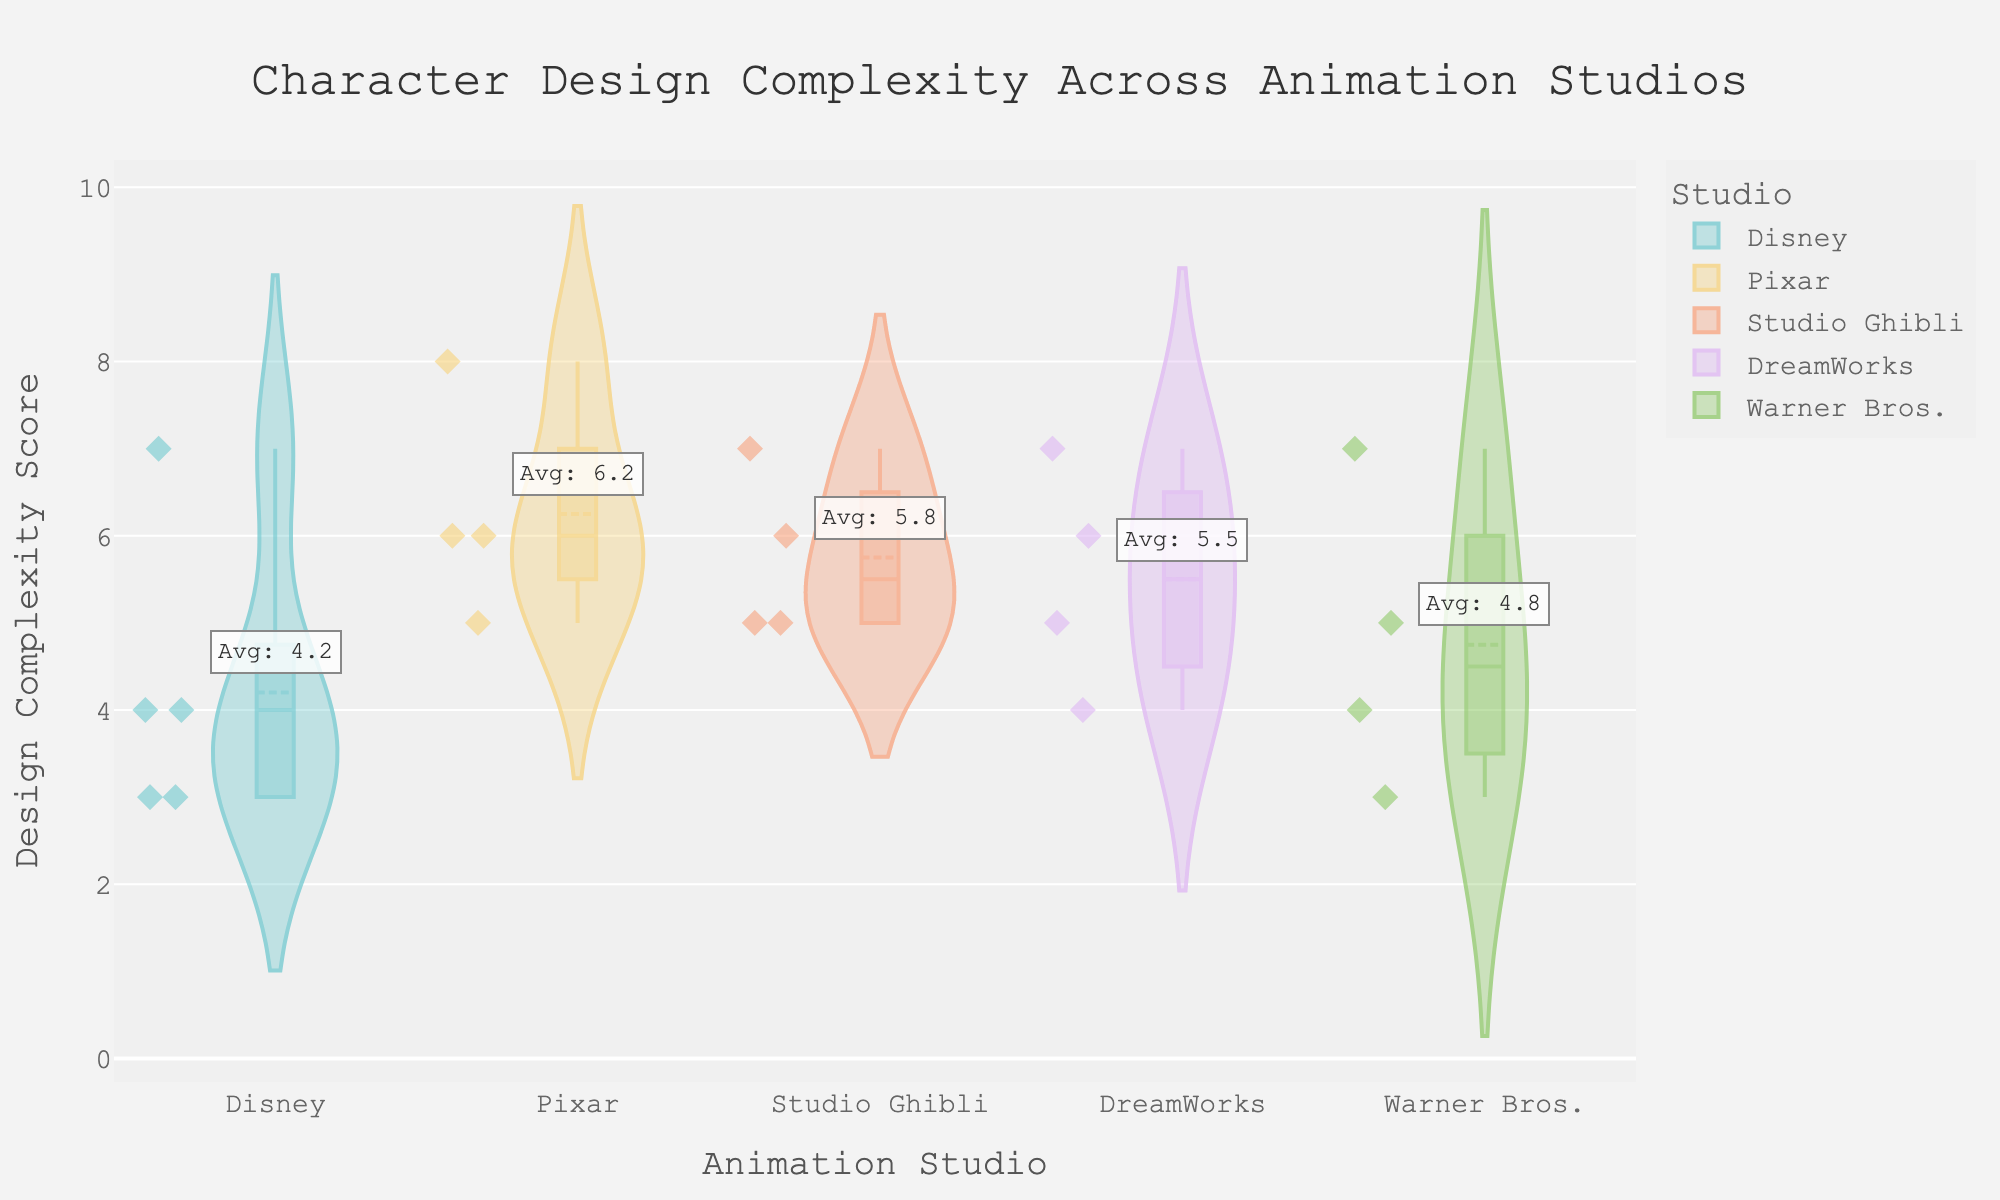What is the title of the figure? The title of the figure is displayed prominently at the top, and it reads "Character Design Complexity Across Animation Studios."
Answer: Character Design Complexity Across Animation Studios Which studio has the character with the highest design complexity score? We need to look at the highest points on the y-axis for each studio. The highest design complexity score is 8, which is associated with Pixar.
Answer: Pixar How many characters from Studio Ghibli are included in the plot? Each data point represents a character, and looking closely at Studio Ghibli's segment, we observe there are four distinct points.
Answer: 4 What is the average design complexity score for characters from DreamWorks? From the figure, we find the individual design complexity scores for DreamWorks: 5, 6, 7, and 4. The average is calculated as (5 + 6 + 7 + 4) / 4 = 5.5.
Answer: 5.5 Which studio has the lowest average design complexity score? By observing the annotation added to each studio's segment, the comparison shows that Warner Bros. has the lowest average design complexity score, indicated as approximately 4.75.
Answer: Warner Bros What is the difference in average design complexity between Disney and Pixar? The average design complexity for Disney is annotated and is around 4.2, and for Pixar, it is approximately 6.25. The difference is 6.25 - 4.2 = 2.05.
Answer: 2.05 Which studio has the widest range in design complexity scores? To determine the range, we look at the vertical spread of each studio’s violin plot. Pixar ranges from 5 to 8, showing a wide spread distinctively.
Answer: Pixar For which studio is the median complexity score equal to the mean complexity score? Both median and mean lines in the violin plot for Warner Bros. lie close to the visible data points' center around 4.75, indicating they are the same.
Answer: Warner Bros How does the design complexity of 'Elsa' compare to 'Hades'? By examining the hover data points, Elsa from Pixar has a design complexity score of 6, whereas Hades from Disney has a complexity score of 7, making Elsa less complex.
Answer: Elsa is less complex than Hades 